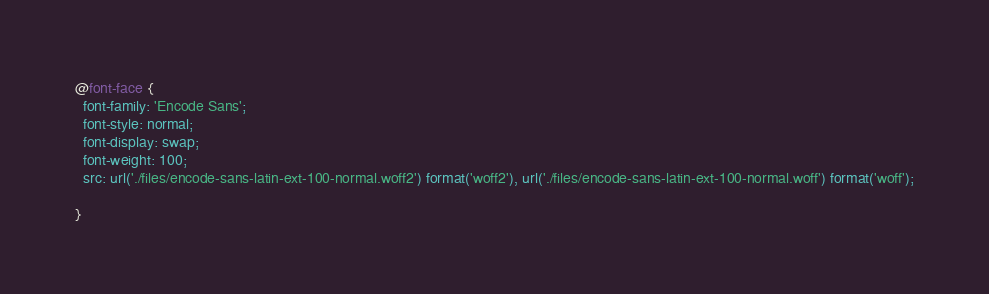Convert code to text. <code><loc_0><loc_0><loc_500><loc_500><_CSS_>@font-face {
  font-family: 'Encode Sans';
  font-style: normal;
  font-display: swap;
  font-weight: 100;
  src: url('./files/encode-sans-latin-ext-100-normal.woff2') format('woff2'), url('./files/encode-sans-latin-ext-100-normal.woff') format('woff');
  
}
</code> 